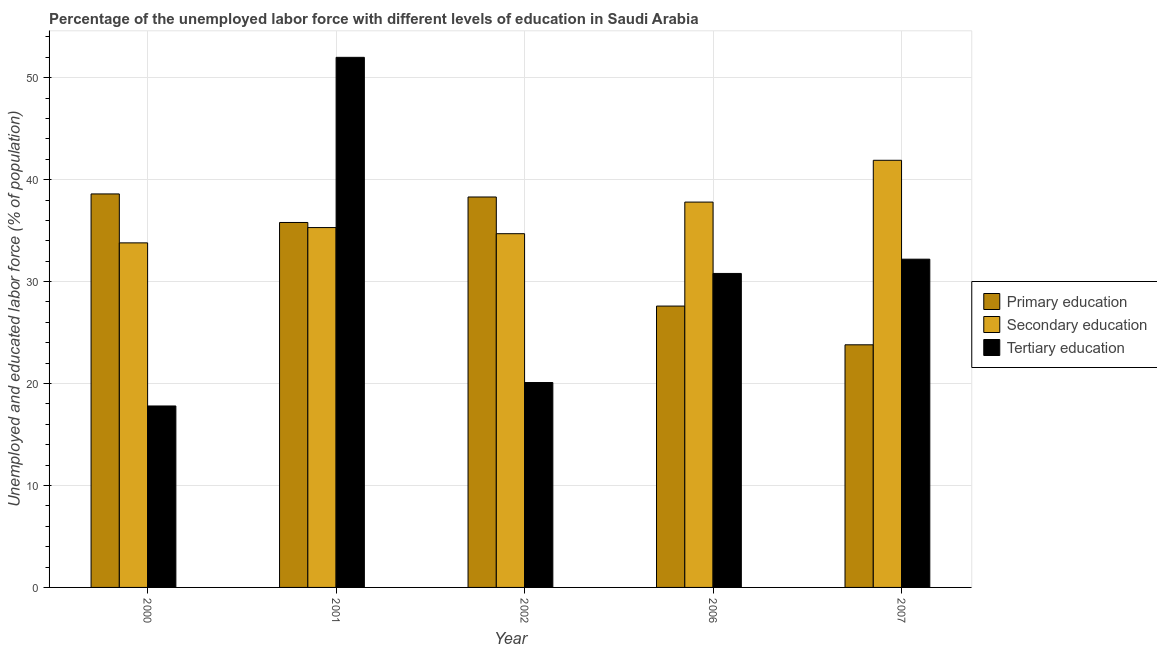How many groups of bars are there?
Ensure brevity in your answer.  5. Are the number of bars per tick equal to the number of legend labels?
Offer a very short reply. Yes. What is the label of the 3rd group of bars from the left?
Your answer should be very brief. 2002. What is the percentage of labor force who received primary education in 2002?
Provide a short and direct response. 38.3. Across all years, what is the maximum percentage of labor force who received secondary education?
Your answer should be compact. 41.9. Across all years, what is the minimum percentage of labor force who received primary education?
Give a very brief answer. 23.8. In which year was the percentage of labor force who received tertiary education maximum?
Keep it short and to the point. 2001. What is the total percentage of labor force who received primary education in the graph?
Offer a terse response. 164.1. What is the difference between the percentage of labor force who received primary education in 2000 and that in 2007?
Your response must be concise. 14.8. What is the difference between the percentage of labor force who received tertiary education in 2006 and the percentage of labor force who received primary education in 2001?
Give a very brief answer. -21.2. What is the average percentage of labor force who received secondary education per year?
Provide a succinct answer. 36.7. In the year 2002, what is the difference between the percentage of labor force who received tertiary education and percentage of labor force who received primary education?
Ensure brevity in your answer.  0. In how many years, is the percentage of labor force who received secondary education greater than 40 %?
Your answer should be compact. 1. What is the ratio of the percentage of labor force who received secondary education in 2000 to that in 2002?
Your answer should be compact. 0.97. What is the difference between the highest and the second highest percentage of labor force who received primary education?
Your response must be concise. 0.3. What is the difference between the highest and the lowest percentage of labor force who received secondary education?
Your response must be concise. 8.1. What does the 3rd bar from the right in 2007 represents?
Keep it short and to the point. Primary education. Is it the case that in every year, the sum of the percentage of labor force who received primary education and percentage of labor force who received secondary education is greater than the percentage of labor force who received tertiary education?
Ensure brevity in your answer.  Yes. How many bars are there?
Keep it short and to the point. 15. How many years are there in the graph?
Provide a succinct answer. 5. Are the values on the major ticks of Y-axis written in scientific E-notation?
Your answer should be very brief. No. How many legend labels are there?
Offer a very short reply. 3. What is the title of the graph?
Your response must be concise. Percentage of the unemployed labor force with different levels of education in Saudi Arabia. What is the label or title of the Y-axis?
Make the answer very short. Unemployed and educated labor force (% of population). What is the Unemployed and educated labor force (% of population) of Primary education in 2000?
Make the answer very short. 38.6. What is the Unemployed and educated labor force (% of population) of Secondary education in 2000?
Ensure brevity in your answer.  33.8. What is the Unemployed and educated labor force (% of population) in Tertiary education in 2000?
Make the answer very short. 17.8. What is the Unemployed and educated labor force (% of population) in Primary education in 2001?
Keep it short and to the point. 35.8. What is the Unemployed and educated labor force (% of population) in Secondary education in 2001?
Your answer should be compact. 35.3. What is the Unemployed and educated labor force (% of population) of Tertiary education in 2001?
Your answer should be compact. 52. What is the Unemployed and educated labor force (% of population) in Primary education in 2002?
Provide a short and direct response. 38.3. What is the Unemployed and educated labor force (% of population) in Secondary education in 2002?
Your response must be concise. 34.7. What is the Unemployed and educated labor force (% of population) in Tertiary education in 2002?
Ensure brevity in your answer.  20.1. What is the Unemployed and educated labor force (% of population) of Primary education in 2006?
Ensure brevity in your answer.  27.6. What is the Unemployed and educated labor force (% of population) of Secondary education in 2006?
Provide a succinct answer. 37.8. What is the Unemployed and educated labor force (% of population) in Tertiary education in 2006?
Give a very brief answer. 30.8. What is the Unemployed and educated labor force (% of population) in Primary education in 2007?
Ensure brevity in your answer.  23.8. What is the Unemployed and educated labor force (% of population) of Secondary education in 2007?
Make the answer very short. 41.9. What is the Unemployed and educated labor force (% of population) of Tertiary education in 2007?
Provide a succinct answer. 32.2. Across all years, what is the maximum Unemployed and educated labor force (% of population) of Primary education?
Your response must be concise. 38.6. Across all years, what is the maximum Unemployed and educated labor force (% of population) of Secondary education?
Your answer should be compact. 41.9. Across all years, what is the maximum Unemployed and educated labor force (% of population) in Tertiary education?
Make the answer very short. 52. Across all years, what is the minimum Unemployed and educated labor force (% of population) of Primary education?
Your response must be concise. 23.8. Across all years, what is the minimum Unemployed and educated labor force (% of population) of Secondary education?
Provide a short and direct response. 33.8. Across all years, what is the minimum Unemployed and educated labor force (% of population) of Tertiary education?
Your answer should be very brief. 17.8. What is the total Unemployed and educated labor force (% of population) in Primary education in the graph?
Provide a succinct answer. 164.1. What is the total Unemployed and educated labor force (% of population) in Secondary education in the graph?
Give a very brief answer. 183.5. What is the total Unemployed and educated labor force (% of population) in Tertiary education in the graph?
Provide a short and direct response. 152.9. What is the difference between the Unemployed and educated labor force (% of population) in Tertiary education in 2000 and that in 2001?
Your response must be concise. -34.2. What is the difference between the Unemployed and educated labor force (% of population) in Secondary education in 2000 and that in 2002?
Provide a short and direct response. -0.9. What is the difference between the Unemployed and educated labor force (% of population) in Tertiary education in 2000 and that in 2002?
Your answer should be compact. -2.3. What is the difference between the Unemployed and educated labor force (% of population) in Tertiary education in 2000 and that in 2006?
Give a very brief answer. -13. What is the difference between the Unemployed and educated labor force (% of population) in Primary education in 2000 and that in 2007?
Keep it short and to the point. 14.8. What is the difference between the Unemployed and educated labor force (% of population) of Tertiary education in 2000 and that in 2007?
Your answer should be very brief. -14.4. What is the difference between the Unemployed and educated labor force (% of population) of Primary education in 2001 and that in 2002?
Make the answer very short. -2.5. What is the difference between the Unemployed and educated labor force (% of population) in Tertiary education in 2001 and that in 2002?
Your answer should be compact. 31.9. What is the difference between the Unemployed and educated labor force (% of population) in Tertiary education in 2001 and that in 2006?
Give a very brief answer. 21.2. What is the difference between the Unemployed and educated labor force (% of population) of Primary education in 2001 and that in 2007?
Keep it short and to the point. 12. What is the difference between the Unemployed and educated labor force (% of population) in Tertiary education in 2001 and that in 2007?
Your answer should be very brief. 19.8. What is the difference between the Unemployed and educated labor force (% of population) of Tertiary education in 2002 and that in 2007?
Ensure brevity in your answer.  -12.1. What is the difference between the Unemployed and educated labor force (% of population) in Tertiary education in 2006 and that in 2007?
Your response must be concise. -1.4. What is the difference between the Unemployed and educated labor force (% of population) of Secondary education in 2000 and the Unemployed and educated labor force (% of population) of Tertiary education in 2001?
Give a very brief answer. -18.2. What is the difference between the Unemployed and educated labor force (% of population) of Primary education in 2000 and the Unemployed and educated labor force (% of population) of Tertiary education in 2002?
Your answer should be very brief. 18.5. What is the difference between the Unemployed and educated labor force (% of population) of Secondary education in 2000 and the Unemployed and educated labor force (% of population) of Tertiary education in 2002?
Keep it short and to the point. 13.7. What is the difference between the Unemployed and educated labor force (% of population) of Primary education in 2000 and the Unemployed and educated labor force (% of population) of Secondary education in 2006?
Offer a very short reply. 0.8. What is the difference between the Unemployed and educated labor force (% of population) of Primary education in 2000 and the Unemployed and educated labor force (% of population) of Tertiary education in 2006?
Provide a short and direct response. 7.8. What is the difference between the Unemployed and educated labor force (% of population) of Secondary education in 2000 and the Unemployed and educated labor force (% of population) of Tertiary education in 2006?
Keep it short and to the point. 3. What is the difference between the Unemployed and educated labor force (% of population) of Primary education in 2000 and the Unemployed and educated labor force (% of population) of Secondary education in 2007?
Provide a succinct answer. -3.3. What is the difference between the Unemployed and educated labor force (% of population) of Primary education in 2000 and the Unemployed and educated labor force (% of population) of Tertiary education in 2007?
Your response must be concise. 6.4. What is the difference between the Unemployed and educated labor force (% of population) in Secondary education in 2000 and the Unemployed and educated labor force (% of population) in Tertiary education in 2007?
Give a very brief answer. 1.6. What is the difference between the Unemployed and educated labor force (% of population) in Secondary education in 2001 and the Unemployed and educated labor force (% of population) in Tertiary education in 2002?
Give a very brief answer. 15.2. What is the difference between the Unemployed and educated labor force (% of population) of Primary education in 2001 and the Unemployed and educated labor force (% of population) of Secondary education in 2006?
Your response must be concise. -2. What is the difference between the Unemployed and educated labor force (% of population) of Secondary education in 2001 and the Unemployed and educated labor force (% of population) of Tertiary education in 2006?
Offer a very short reply. 4.5. What is the difference between the Unemployed and educated labor force (% of population) in Primary education in 2001 and the Unemployed and educated labor force (% of population) in Secondary education in 2007?
Offer a terse response. -6.1. What is the difference between the Unemployed and educated labor force (% of population) in Secondary education in 2001 and the Unemployed and educated labor force (% of population) in Tertiary education in 2007?
Give a very brief answer. 3.1. What is the difference between the Unemployed and educated labor force (% of population) of Primary education in 2002 and the Unemployed and educated labor force (% of population) of Tertiary education in 2006?
Keep it short and to the point. 7.5. What is the difference between the Unemployed and educated labor force (% of population) of Secondary education in 2002 and the Unemployed and educated labor force (% of population) of Tertiary education in 2007?
Keep it short and to the point. 2.5. What is the difference between the Unemployed and educated labor force (% of population) of Primary education in 2006 and the Unemployed and educated labor force (% of population) of Secondary education in 2007?
Provide a succinct answer. -14.3. What is the difference between the Unemployed and educated labor force (% of population) in Primary education in 2006 and the Unemployed and educated labor force (% of population) in Tertiary education in 2007?
Your answer should be very brief. -4.6. What is the average Unemployed and educated labor force (% of population) of Primary education per year?
Give a very brief answer. 32.82. What is the average Unemployed and educated labor force (% of population) of Secondary education per year?
Make the answer very short. 36.7. What is the average Unemployed and educated labor force (% of population) in Tertiary education per year?
Your response must be concise. 30.58. In the year 2000, what is the difference between the Unemployed and educated labor force (% of population) in Primary education and Unemployed and educated labor force (% of population) in Tertiary education?
Your answer should be compact. 20.8. In the year 2000, what is the difference between the Unemployed and educated labor force (% of population) of Secondary education and Unemployed and educated labor force (% of population) of Tertiary education?
Offer a very short reply. 16. In the year 2001, what is the difference between the Unemployed and educated labor force (% of population) in Primary education and Unemployed and educated labor force (% of population) in Secondary education?
Provide a short and direct response. 0.5. In the year 2001, what is the difference between the Unemployed and educated labor force (% of population) in Primary education and Unemployed and educated labor force (% of population) in Tertiary education?
Offer a terse response. -16.2. In the year 2001, what is the difference between the Unemployed and educated labor force (% of population) of Secondary education and Unemployed and educated labor force (% of population) of Tertiary education?
Your response must be concise. -16.7. In the year 2002, what is the difference between the Unemployed and educated labor force (% of population) of Primary education and Unemployed and educated labor force (% of population) of Secondary education?
Keep it short and to the point. 3.6. In the year 2002, what is the difference between the Unemployed and educated labor force (% of population) of Primary education and Unemployed and educated labor force (% of population) of Tertiary education?
Your answer should be very brief. 18.2. In the year 2002, what is the difference between the Unemployed and educated labor force (% of population) of Secondary education and Unemployed and educated labor force (% of population) of Tertiary education?
Give a very brief answer. 14.6. In the year 2006, what is the difference between the Unemployed and educated labor force (% of population) of Primary education and Unemployed and educated labor force (% of population) of Tertiary education?
Your response must be concise. -3.2. In the year 2007, what is the difference between the Unemployed and educated labor force (% of population) in Primary education and Unemployed and educated labor force (% of population) in Secondary education?
Give a very brief answer. -18.1. In the year 2007, what is the difference between the Unemployed and educated labor force (% of population) of Secondary education and Unemployed and educated labor force (% of population) of Tertiary education?
Make the answer very short. 9.7. What is the ratio of the Unemployed and educated labor force (% of population) of Primary education in 2000 to that in 2001?
Provide a short and direct response. 1.08. What is the ratio of the Unemployed and educated labor force (% of population) of Secondary education in 2000 to that in 2001?
Ensure brevity in your answer.  0.96. What is the ratio of the Unemployed and educated labor force (% of population) of Tertiary education in 2000 to that in 2001?
Give a very brief answer. 0.34. What is the ratio of the Unemployed and educated labor force (% of population) in Primary education in 2000 to that in 2002?
Make the answer very short. 1.01. What is the ratio of the Unemployed and educated labor force (% of population) in Secondary education in 2000 to that in 2002?
Your answer should be compact. 0.97. What is the ratio of the Unemployed and educated labor force (% of population) of Tertiary education in 2000 to that in 2002?
Offer a very short reply. 0.89. What is the ratio of the Unemployed and educated labor force (% of population) in Primary education in 2000 to that in 2006?
Give a very brief answer. 1.4. What is the ratio of the Unemployed and educated labor force (% of population) in Secondary education in 2000 to that in 2006?
Ensure brevity in your answer.  0.89. What is the ratio of the Unemployed and educated labor force (% of population) of Tertiary education in 2000 to that in 2006?
Ensure brevity in your answer.  0.58. What is the ratio of the Unemployed and educated labor force (% of population) of Primary education in 2000 to that in 2007?
Give a very brief answer. 1.62. What is the ratio of the Unemployed and educated labor force (% of population) in Secondary education in 2000 to that in 2007?
Offer a terse response. 0.81. What is the ratio of the Unemployed and educated labor force (% of population) of Tertiary education in 2000 to that in 2007?
Keep it short and to the point. 0.55. What is the ratio of the Unemployed and educated labor force (% of population) of Primary education in 2001 to that in 2002?
Offer a terse response. 0.93. What is the ratio of the Unemployed and educated labor force (% of population) in Secondary education in 2001 to that in 2002?
Keep it short and to the point. 1.02. What is the ratio of the Unemployed and educated labor force (% of population) of Tertiary education in 2001 to that in 2002?
Your response must be concise. 2.59. What is the ratio of the Unemployed and educated labor force (% of population) in Primary education in 2001 to that in 2006?
Provide a succinct answer. 1.3. What is the ratio of the Unemployed and educated labor force (% of population) of Secondary education in 2001 to that in 2006?
Give a very brief answer. 0.93. What is the ratio of the Unemployed and educated labor force (% of population) of Tertiary education in 2001 to that in 2006?
Ensure brevity in your answer.  1.69. What is the ratio of the Unemployed and educated labor force (% of population) of Primary education in 2001 to that in 2007?
Offer a terse response. 1.5. What is the ratio of the Unemployed and educated labor force (% of population) of Secondary education in 2001 to that in 2007?
Make the answer very short. 0.84. What is the ratio of the Unemployed and educated labor force (% of population) in Tertiary education in 2001 to that in 2007?
Your response must be concise. 1.61. What is the ratio of the Unemployed and educated labor force (% of population) in Primary education in 2002 to that in 2006?
Your answer should be compact. 1.39. What is the ratio of the Unemployed and educated labor force (% of population) in Secondary education in 2002 to that in 2006?
Keep it short and to the point. 0.92. What is the ratio of the Unemployed and educated labor force (% of population) in Tertiary education in 2002 to that in 2006?
Offer a very short reply. 0.65. What is the ratio of the Unemployed and educated labor force (% of population) of Primary education in 2002 to that in 2007?
Offer a very short reply. 1.61. What is the ratio of the Unemployed and educated labor force (% of population) in Secondary education in 2002 to that in 2007?
Keep it short and to the point. 0.83. What is the ratio of the Unemployed and educated labor force (% of population) of Tertiary education in 2002 to that in 2007?
Your answer should be very brief. 0.62. What is the ratio of the Unemployed and educated labor force (% of population) of Primary education in 2006 to that in 2007?
Keep it short and to the point. 1.16. What is the ratio of the Unemployed and educated labor force (% of population) in Secondary education in 2006 to that in 2007?
Keep it short and to the point. 0.9. What is the ratio of the Unemployed and educated labor force (% of population) of Tertiary education in 2006 to that in 2007?
Keep it short and to the point. 0.96. What is the difference between the highest and the second highest Unemployed and educated labor force (% of population) of Secondary education?
Provide a short and direct response. 4.1. What is the difference between the highest and the second highest Unemployed and educated labor force (% of population) in Tertiary education?
Keep it short and to the point. 19.8. What is the difference between the highest and the lowest Unemployed and educated labor force (% of population) in Secondary education?
Keep it short and to the point. 8.1. What is the difference between the highest and the lowest Unemployed and educated labor force (% of population) in Tertiary education?
Ensure brevity in your answer.  34.2. 